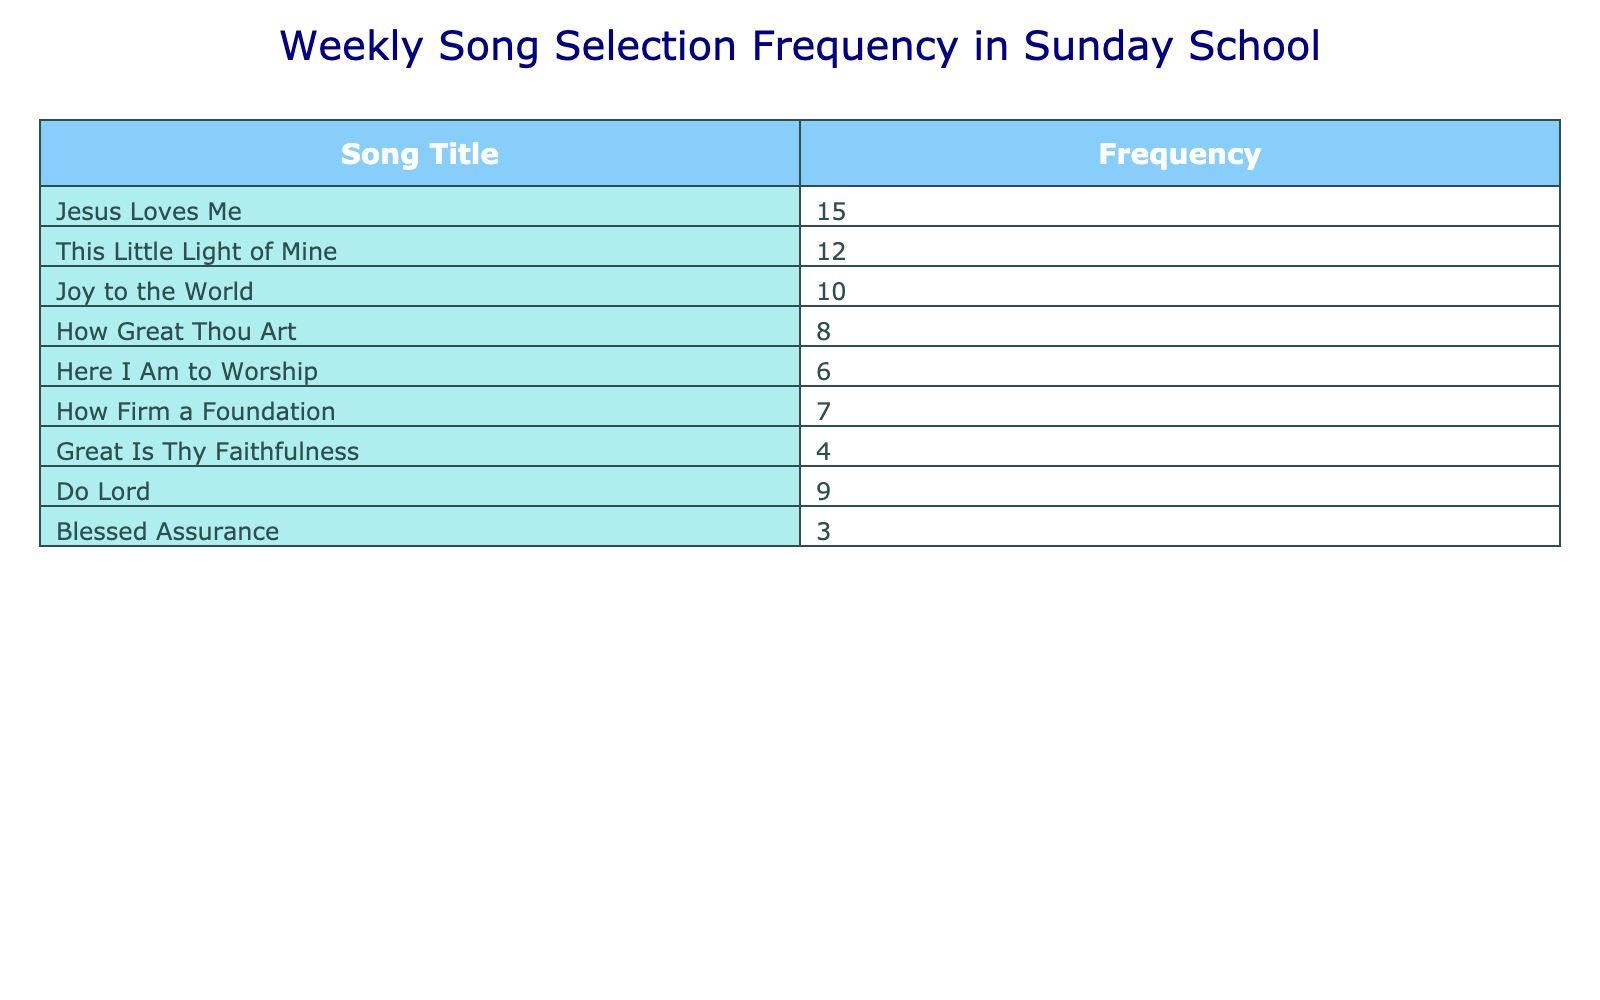What is the most frequently selected song? The table displays a frequency count for each song. By looking at the frequency values, "Jesus Loves Me" has the highest frequency at 15.
Answer: Jesus Loves Me How many songs have a frequency of 10 or more? We need to check each frequency: "Jesus Loves Me" (15), "This Little Light of Mine" (12), "Joy to the World" (10). The total count of songs is three.
Answer: 3 What is the total frequency of all songs in the table? We sum up all the frequencies: 15 + 12 + 10 + 8 + 6 + 7 + 4 + 9 + 3 = 74. Therefore, the total frequency is 74.
Answer: 74 Is "Great Is Thy Faithfulness" selected as frequently as "Do Lord"? "Great Is Thy Faithfulness" has a frequency of 4, while "Do Lord" has a frequency of 9. Since 4 is less than 9, the answer is no.
Answer: No What is the average frequency of all songs in the list? To find the average, we take the total frequency (74) and divide it by the number of songs (9), resulting in 74/9 which equals approximately 8.22.
Answer: 8.22 Which song has the lowest frequency? Looking through the frequency values, "Blessed Assurance" has the lowest frequency of 3.
Answer: Blessed Assurance How many more times was "This Little Light of Mine" selected compared to "Great Is Thy Faithfulness"? "This Little Light of Mine" has a frequency of 12 and "Great Is Thy Faithfulness" has a frequency of 4. The difference is calculated as 12 - 4 = 8.
Answer: 8 Was "How Great Thou Art" selected more times than "Here I Am to Worship"? "How Great Thou Art" has a frequency of 8 and "Here I Am to Worship" has a frequency of 6. Since 8 is greater than 6, the answer is yes.
Answer: Yes What is the total frequency of songs that were selected less than 5 times? The songs with frequency less than 5 are "Great Is Thy Faithfulness" (4) and "Blessed Assurance" (3). Adding these gives me 4 + 3 = 7.
Answer: 7 